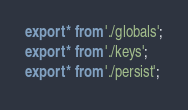<code> <loc_0><loc_0><loc_500><loc_500><_TypeScript_>export * from './globals';
export * from './keys';
export * from './persist';
</code> 